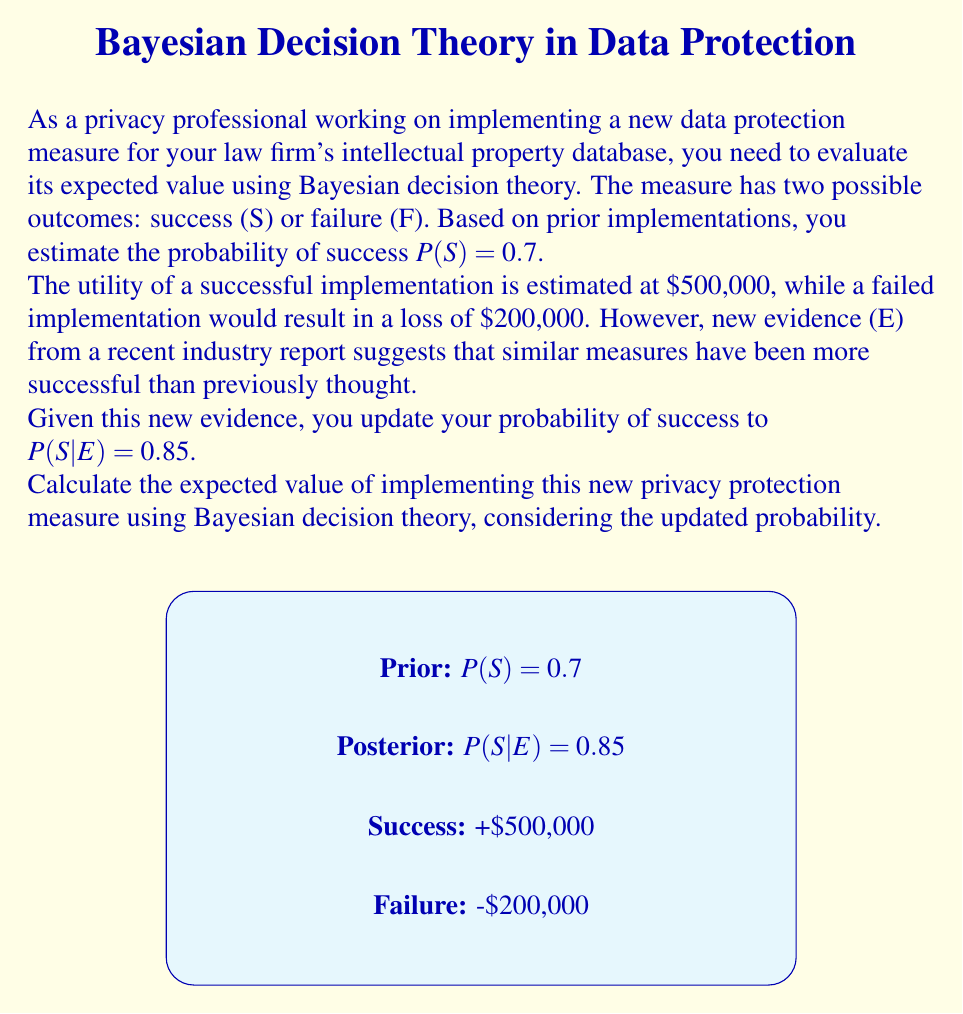Show me your answer to this math problem. To solve this problem using Bayesian decision theory, we'll follow these steps:

1) First, let's define our variables:
   S: Success
   F: Failure
   E: New evidence

2) Given probabilities:
   P(S|E) = 0.85 (posterior probability of success given new evidence)
   P(F|E) = 1 - P(S|E) = 0.15 (probability of failure given new evidence)

3) Utilities:
   U(S) = $500,000 (utility of success)
   U(F) = -$200,000 (utility of failure)

4) The expected value (EV) is calculated using the formula:
   $$ EV = P(S|E) \cdot U(S) + P(F|E) \cdot U(F) $$

5) Let's substitute our values:
   $$ EV = 0.85 \cdot \$500,000 + 0.15 \cdot (-\$200,000) $$

6) Now, let's calculate:
   $$ EV = \$425,000 - \$30,000 = \$395,000 $$

Therefore, the expected value of implementing the new privacy protection measure, considering the updated probability based on new evidence, is $395,000.
Answer: $395,000 